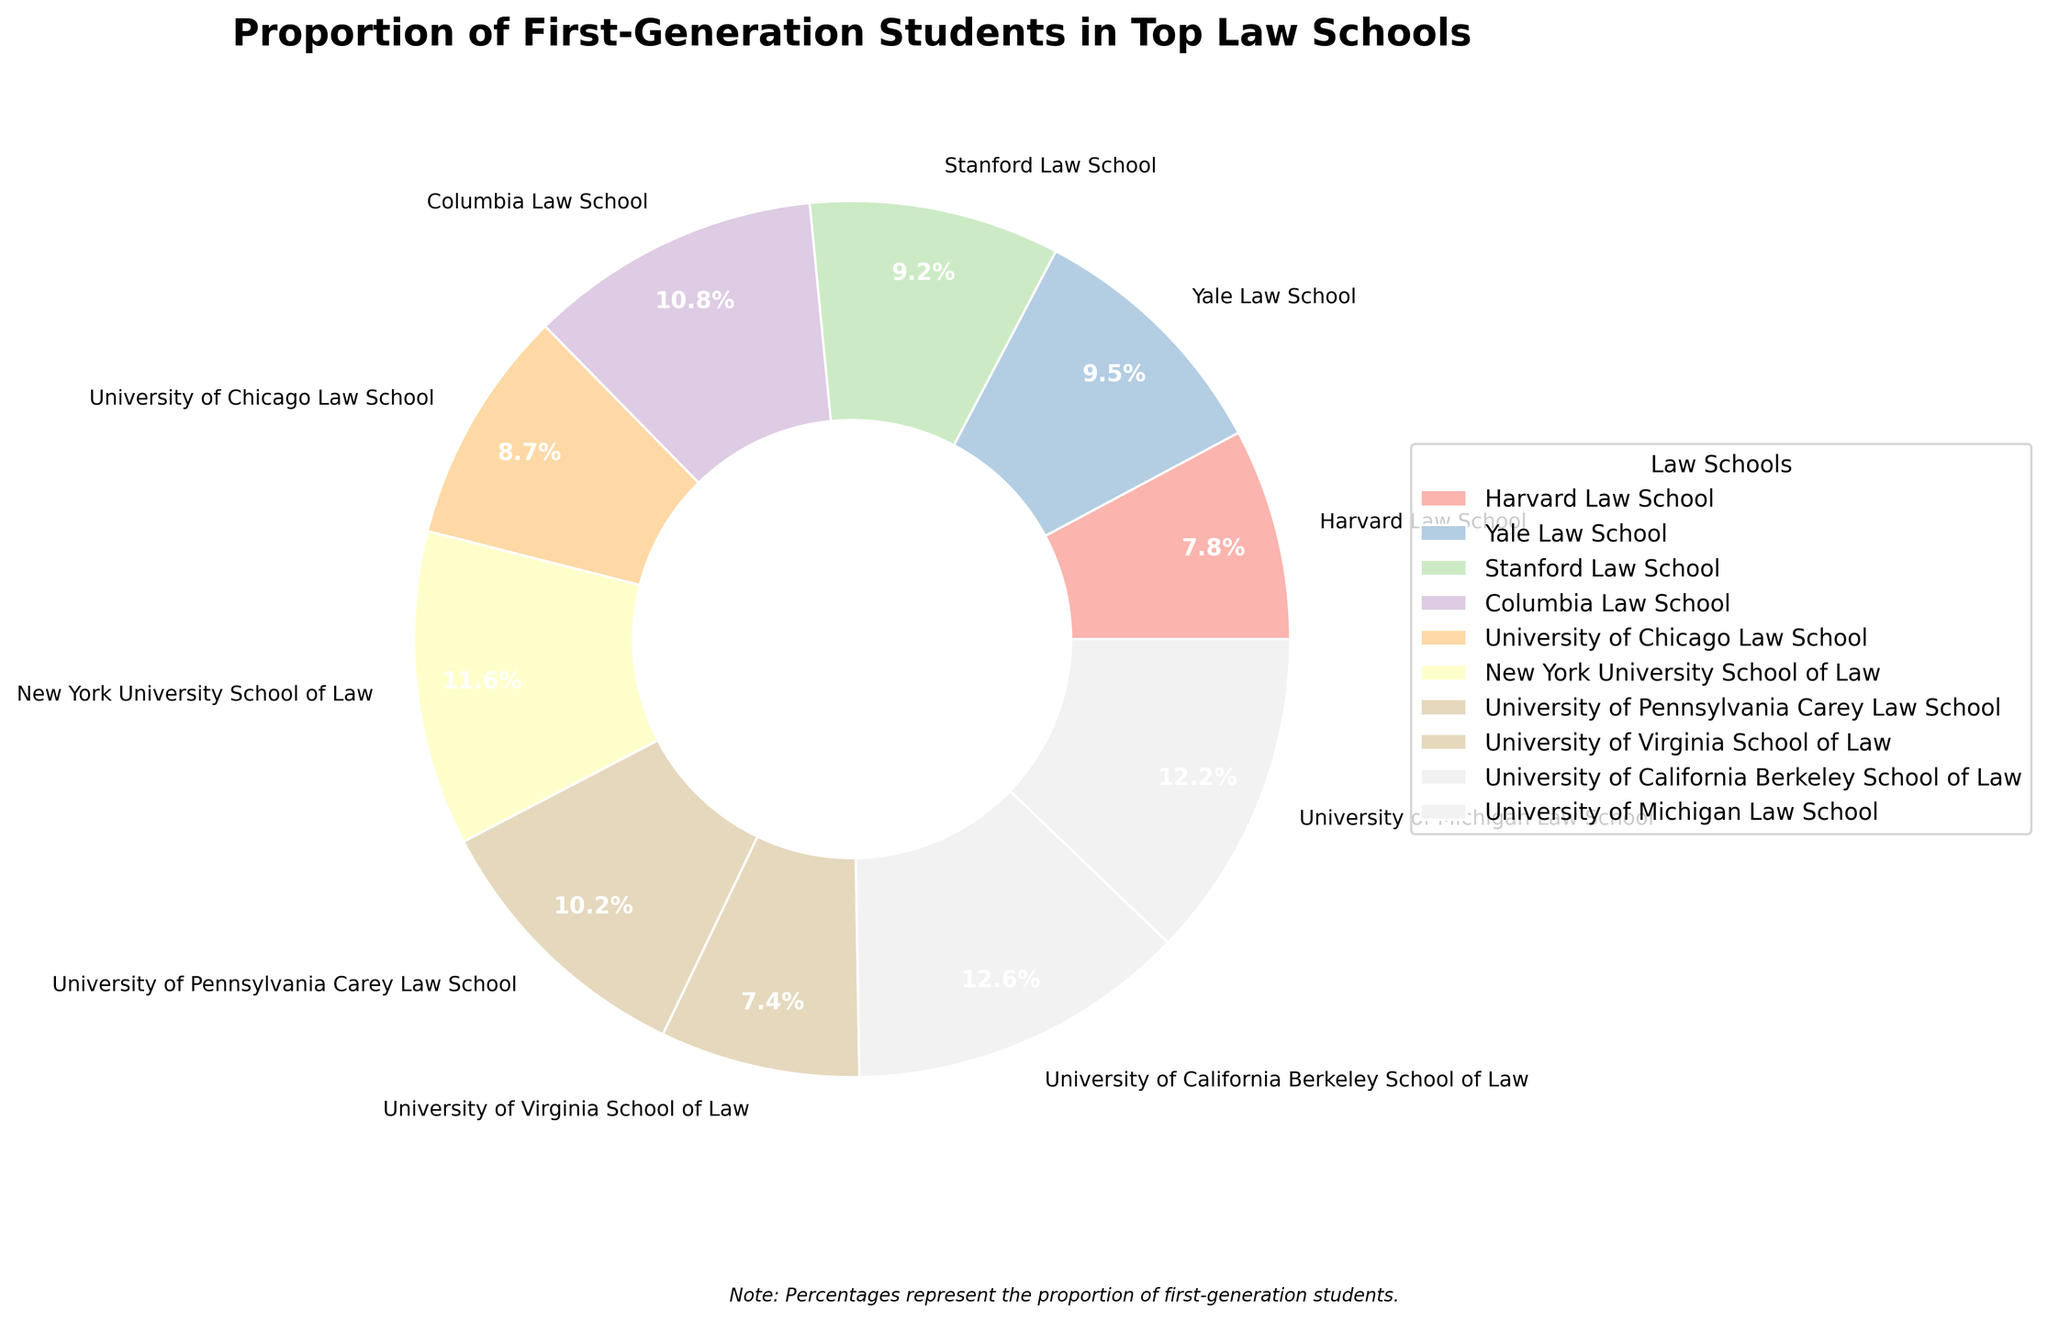Which law school has the highest proportion of first-generation students? By examining the wedges and the percentages on the pie chart, the University of California Berkeley School of Law has the highest proportion at 20.1%.
Answer: University of California Berkeley School of Law Which law school has the lowest proportion of first-generation students? By looking at the smallest wedge and reading the corresponding percentage, the University of Virginia School of Law has the lowest proportion at 11.8%.
Answer: University of Virginia School of Law What is the difference in the proportion of first-generation students between Harvard Law School and Yale Law School? From the chart, Harvard has 12.5% and Yale has 15.2%. Subtracting these values gives 15.2% - 12.5% = 2.7%.
Answer: 2.7% Which schools have a proportion of first-generation students greater than 15%? The schools with more than 15% can be identified by their wedge sizes and percentages: Yale (15.2%), Stanford (14.8%), Columbia (17.3%), NYU (18.6%), UPenn (16.4%), UC Berkeley (20.1%), and Michigan (19.5%).
Answer: Yale, Columbia, NYU, UPenn, UC Berkeley, Michigan What is the combined proportion of first-generation students in Columbia Law School and the University of Pennsylvania Carey Law School? Columbia has 17.3% and UPenn has 16.4%. Adding these values gives 17.3% + 16.4% = 33.7%.
Answer: 33.7% How does the proportion of first-generation students at Stanford compare to that of the University of Chicago? From the chart, Stanford has 14.8% and Chicago has 13.9%. Stanford's proportion is higher.
Answer: Stanford's is higher Which color represents the University of Michigan Law School in the pie chart? By matching the percentages with the colors on the pie chart, locate the wedge with 19.5%. The corresponding color is light green.
Answer: light green What's the average proportion of first-generation students among all schools? Sum all the percentages (12.5% + 15.2% + 14.8% + 17.3% + 13.9% + 18.6% + 16.4% + 11.8% + 20.1% + 19.5%) to get 160.1%. Divide by the number of schools (10) to get 160.1% / 10 = 16.01%.
Answer: 16.01% Which schools have a proportion of first-generation students below the average proportion? Comparing each school's proportion to the average of 16.01%, the schools below average are: Harvard (12.5%), Stanford (14.8%), Chicago (13.9%), Virginia (11.8%).
Answer: Harvard, Stanford, Chicago, Virginia 